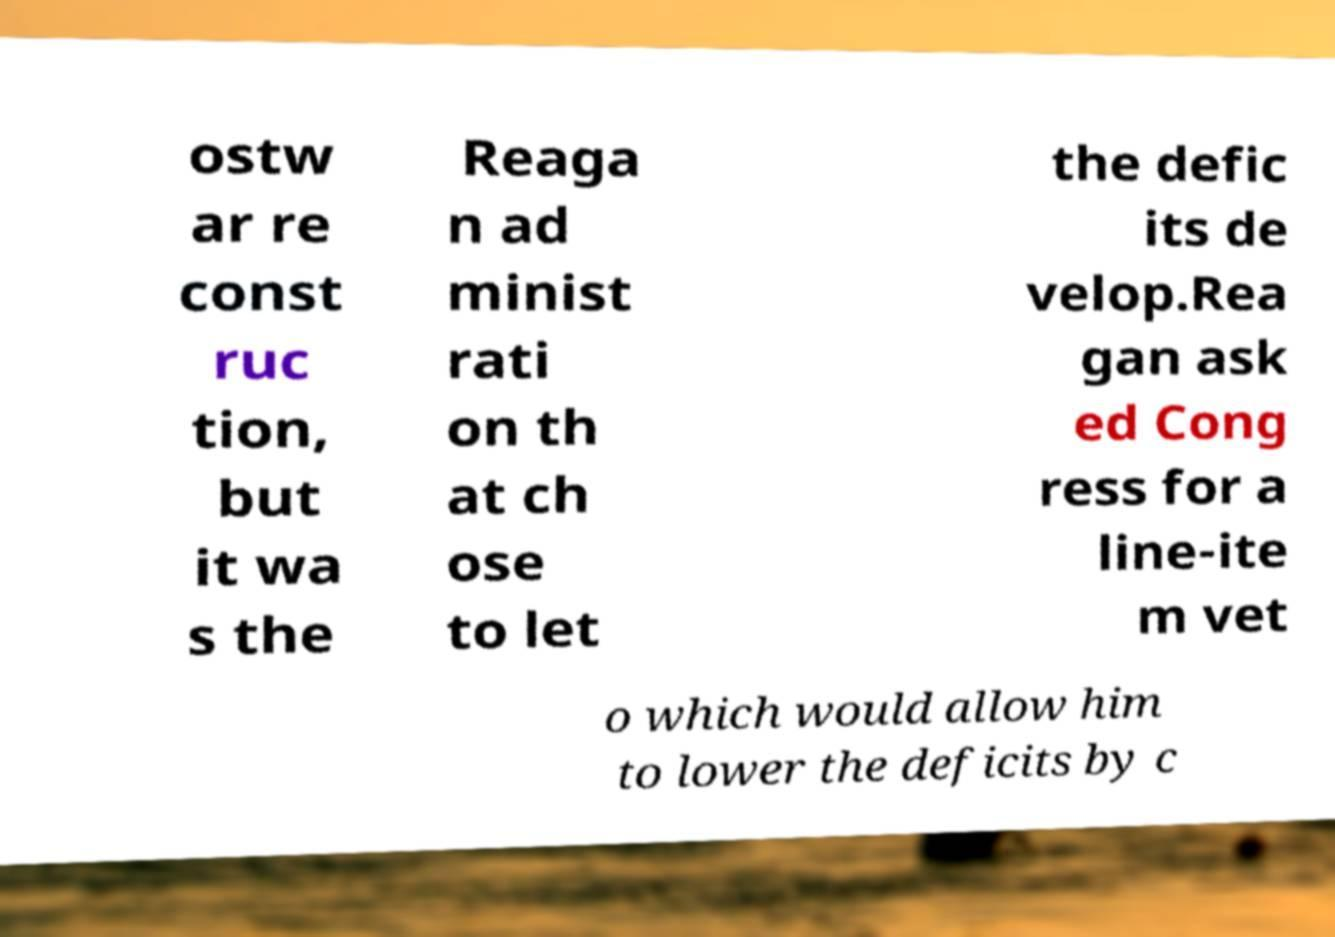Can you accurately transcribe the text from the provided image for me? ostw ar re const ruc tion, but it wa s the Reaga n ad minist rati on th at ch ose to let the defic its de velop.Rea gan ask ed Cong ress for a line-ite m vet o which would allow him to lower the deficits by c 